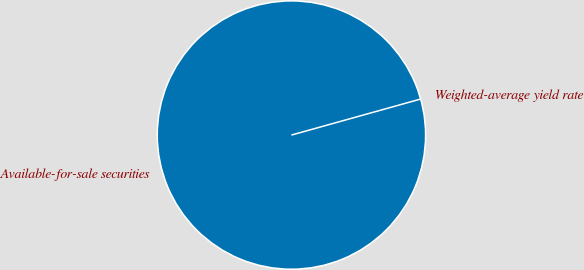Convert chart. <chart><loc_0><loc_0><loc_500><loc_500><pie_chart><fcel>Available-for-sale securities<fcel>Weighted-average yield rate<nl><fcel>100.0%<fcel>0.0%<nl></chart> 